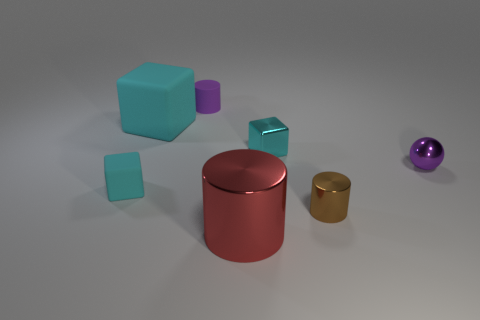What material is the large cyan thing that is the same shape as the tiny cyan matte thing?
Ensure brevity in your answer.  Rubber. There is a purple object on the right side of the purple matte object; is it the same shape as the cyan object to the right of the small purple rubber object?
Offer a terse response. No. Is the number of brown metal balls greater than the number of tiny balls?
Ensure brevity in your answer.  No. The rubber cylinder has what size?
Give a very brief answer. Small. How many other things are there of the same color as the sphere?
Provide a succinct answer. 1. Is the cylinder that is on the left side of the red metallic cylinder made of the same material as the large red object?
Give a very brief answer. No. Are there fewer large matte objects that are behind the big matte thing than red cylinders that are on the left side of the red cylinder?
Your answer should be very brief. No. How many other objects are there of the same material as the ball?
Your answer should be very brief. 3. There is another cube that is the same size as the cyan metallic block; what is it made of?
Your answer should be compact. Rubber. Are there fewer small cylinders behind the tiny purple rubber cylinder than tiny rubber blocks?
Offer a very short reply. Yes. 